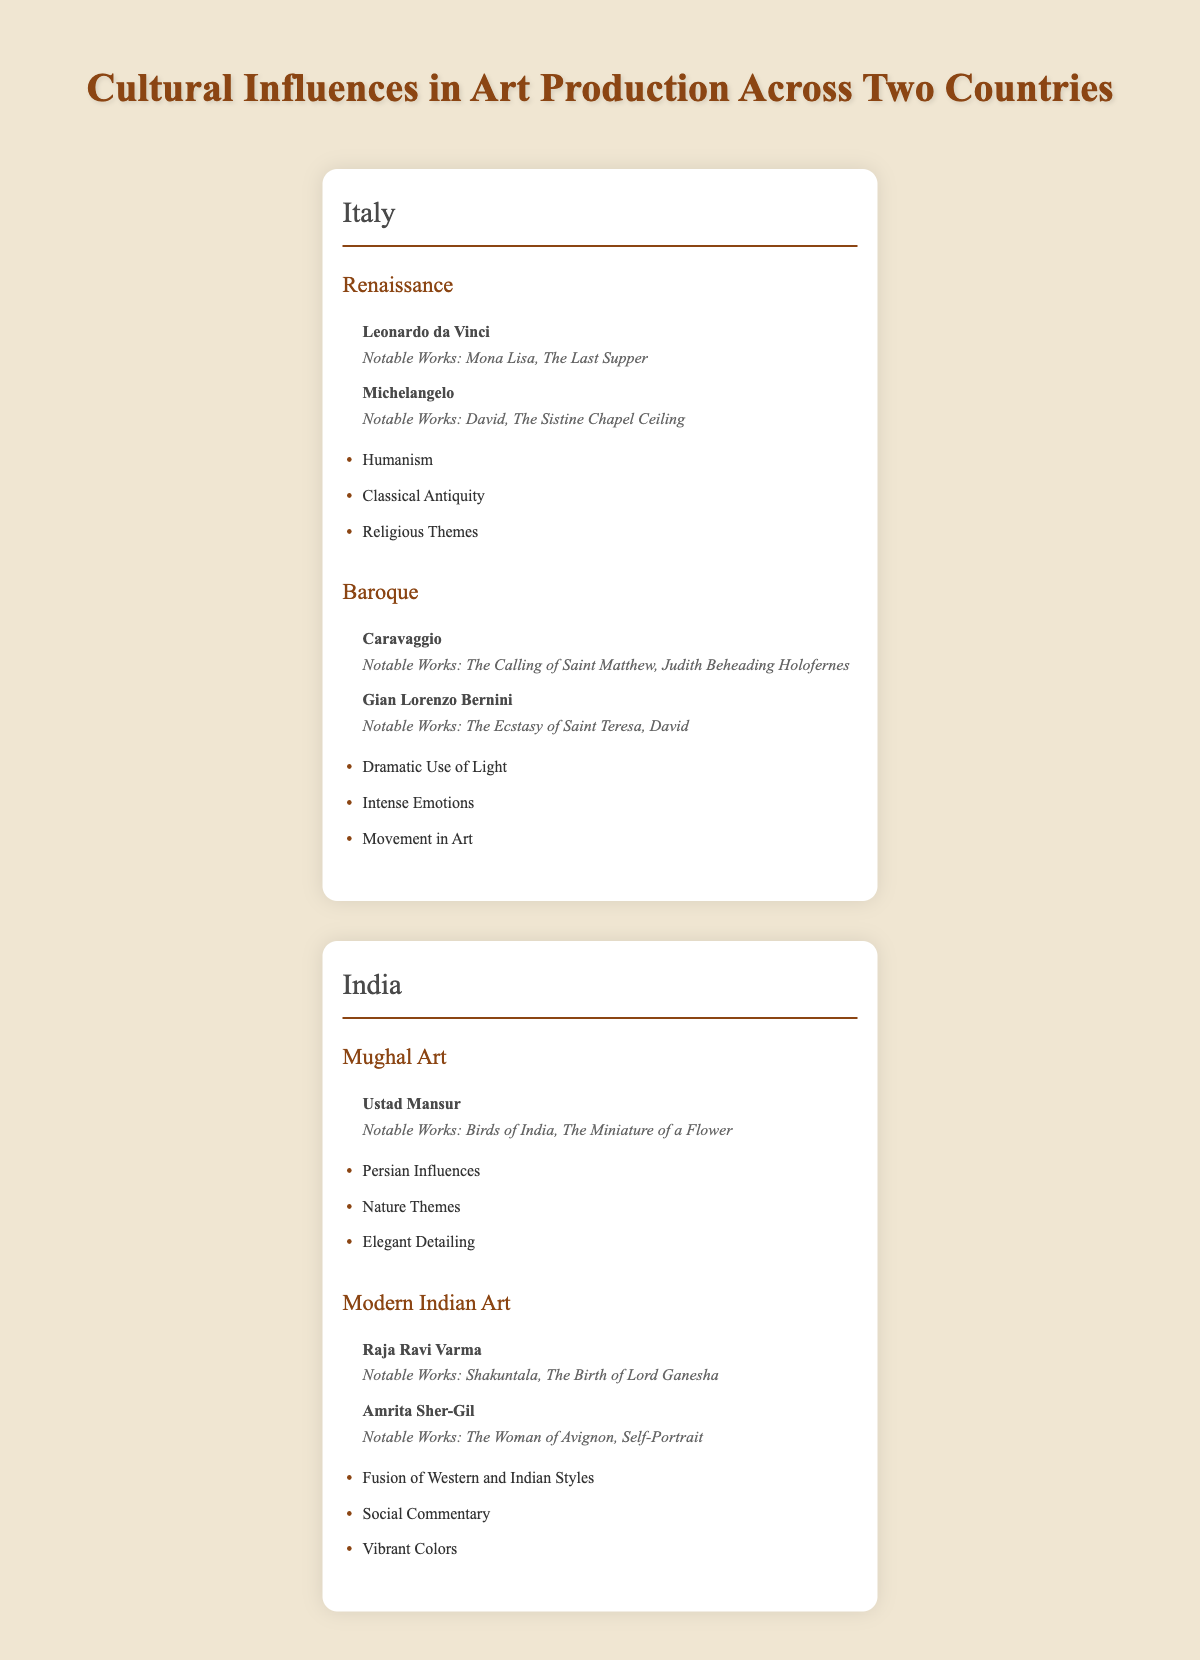What are the notable works of Leonardo da Vinci? The table lists Leonardo da Vinci as a key artist in the Renaissance movement in Italy, with his notable works being "Mona Lisa" and "The Last Supper."
Answer: Mona Lisa, The Last Supper Which cultural elements are associated with Baroque art in Italy? According to the table, the cultural elements associated with Baroque art include "Dramatic Use of Light," "Intense Emotions," and "Movement in Art."
Answer: Dramatic Use of Light, Intense Emotions, Movement in Art Is Raja Ravi Varma recognized as a key artist in Mughal Art? The table shows that Raja Ravi Varma is associated with the Modern Indian Art movement, not Mughal Art, which features Ustad Mansur as a key artist. Therefore, the statement is false.
Answer: No How many notable works does Amrita Sher-Gil have listed? Amrita Sher-Gil is listed in the Modern Indian Art movement, with two notable works noted in the table: "The Woman of Avignon" and "Self-Portrait."
Answer: 2 What is the sum of the total key artists in both countries? In Italy, there are four key artists (2 from Renaissance and 2 from Baroque). In India, there are three key artists (1 from Mughal Art and 2 from Modern Indian Art), giving a total of 4 + 3 = 7 key artists.
Answer: 7 Which cultural elements of Modern Indian Art focus on color themes? The table states that modern Indian Art includes "Fusion of Western and Indian Styles," "Social Commentary," and "Vibrant Colors," where the last element explicitly relates to colors.
Answer: Vibrant Colors Identify the shared cultural element between both countries in art movements. Both cultural contexts feature themes influenced by nature. In Italy, elements such as "Dramatic Use of Light" in Baroque can reflect the nature theme, while Mughal Art mentions "Nature Themes." Therefore, nature plays a prominent role in art for both.
Answer: Nature Themes What can you say about the emotional expression in Baroque compared to Modern Indian Art? The table highlights "Intense Emotions" as a cultural element in Baroque art, while Modern Indian Art does not directly mention emotional expression but rather focuses on social commentary, which can involve emotions. Thus, Baroque has a clearer emphasis on emotions compared to Modern Indian Art's indirect approach.
Answer: Baroque emphasizes emotions more distinctly 